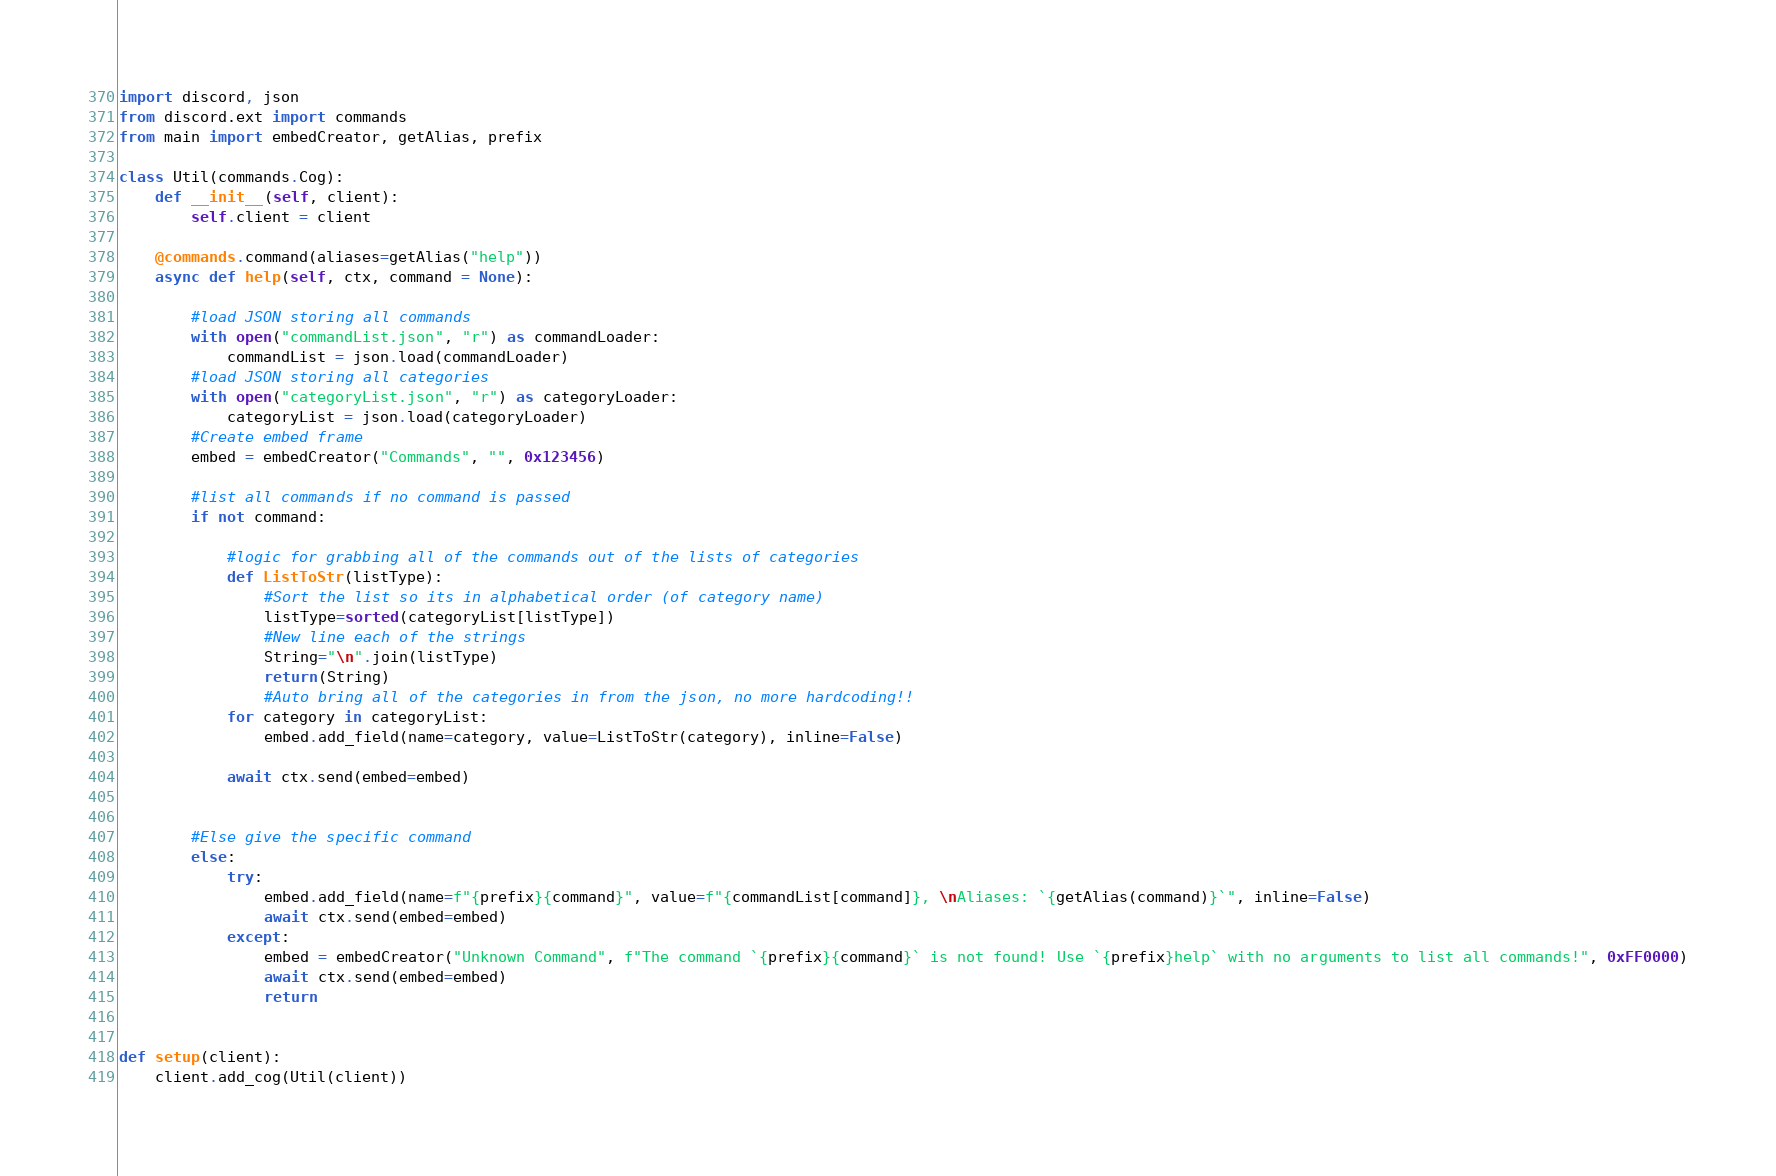Convert code to text. <code><loc_0><loc_0><loc_500><loc_500><_Python_>import discord, json
from discord.ext import commands
from main import embedCreator, getAlias, prefix

class Util(commands.Cog):
    def __init__(self, client):
        self.client = client

    @commands.command(aliases=getAlias("help"))
    async def help(self, ctx, command = None):

        #load JSON storing all commands
        with open("commandList.json", "r") as commandLoader:
            commandList = json.load(commandLoader)
        #load JSON storing all categories
        with open("categoryList.json", "r") as categoryLoader:
            categoryList = json.load(categoryLoader)
        #Create embed frame
        embed = embedCreator("Commands", "", 0x123456)

        #list all commands if no command is passed
        if not command:

            #logic for grabbing all of the commands out of the lists of categories
            def ListToStr(listType):
                #Sort the list so its in alphabetical order (of category name)
                listType=sorted(categoryList[listType])
                #New line each of the strings
                String="\n".join(listType)
                return(String)
                #Auto bring all of the categories in from the json, no more hardcoding!!
            for category in categoryList:
                embed.add_field(name=category, value=ListToStr(category), inline=False)

            await ctx.send(embed=embed)


        #Else give the specific command
        else:
            try:
                embed.add_field(name=f"{prefix}{command}", value=f"{commandList[command]}, \nAliases: `{getAlias(command)}`", inline=False)
                await ctx.send(embed=embed)
            except:
                embed = embedCreator("Unknown Command", f"The command `{prefix}{command}` is not found! Use `{prefix}help` with no arguments to list all commands!", 0xFF0000)
                await ctx.send(embed=embed)
                return


def setup(client):
    client.add_cog(Util(client))
</code> 